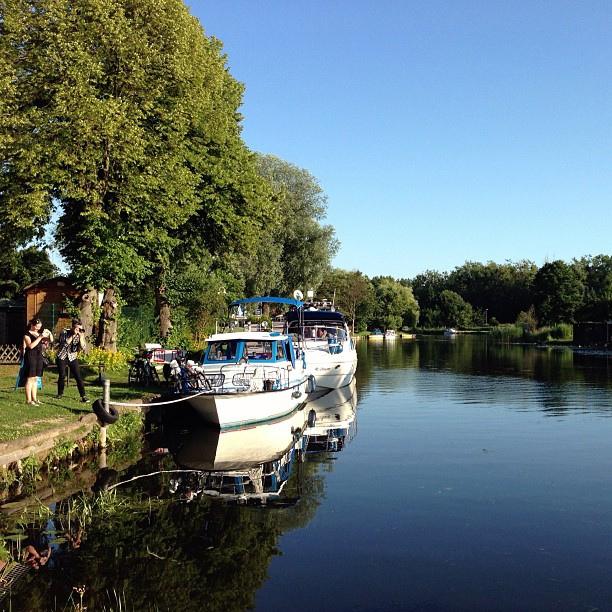What color is the sky?
Write a very short answer. Blue. How many boats are in the picture?
Answer briefly. 2. Is the water full of waves?
Be succinct. No. Is this boat both blue and white?
Short answer required. Yes. 